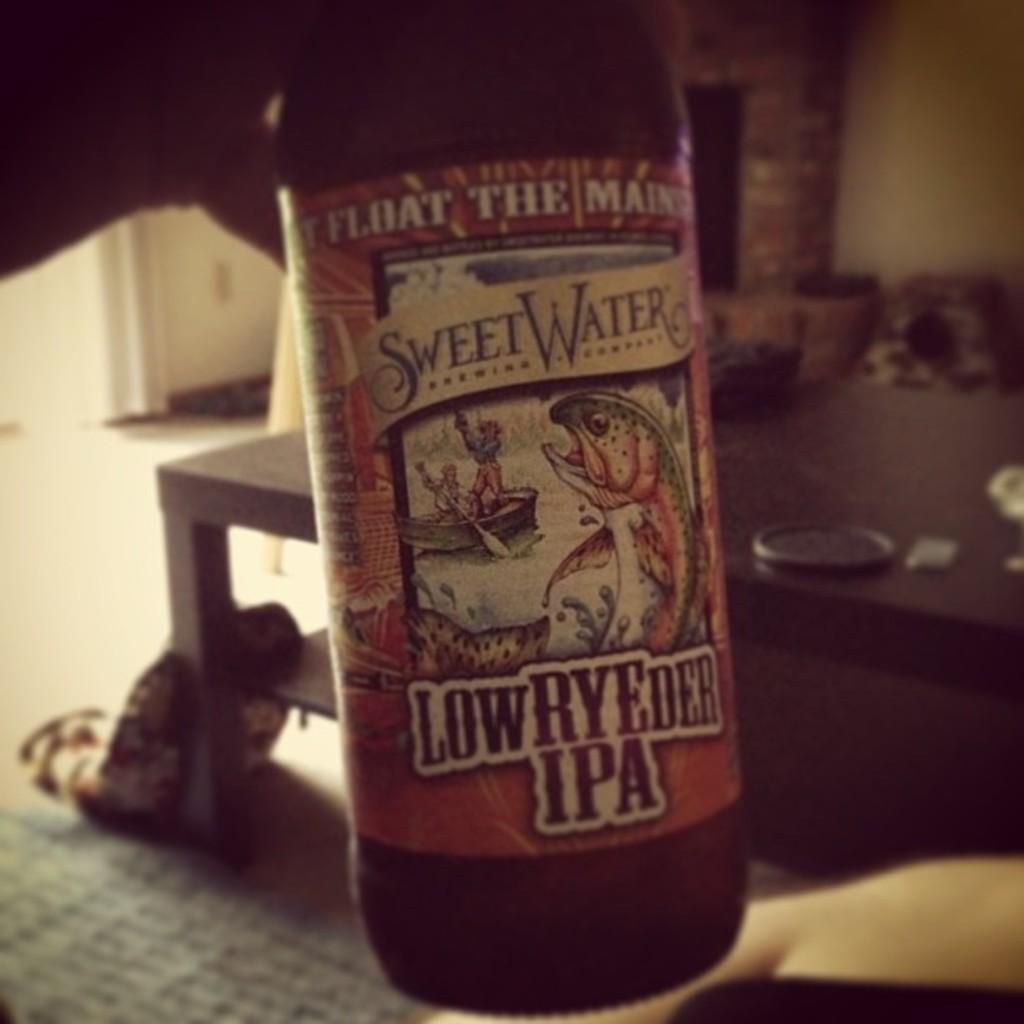Provide a one-sentence caption for the provided image. A bottle of SweetWater LowRYEder IPA is being held in front of a brick fireplace. 